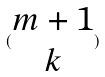Convert formula to latex. <formula><loc_0><loc_0><loc_500><loc_500>( \begin{matrix} m + 1 \\ k \end{matrix} )</formula> 